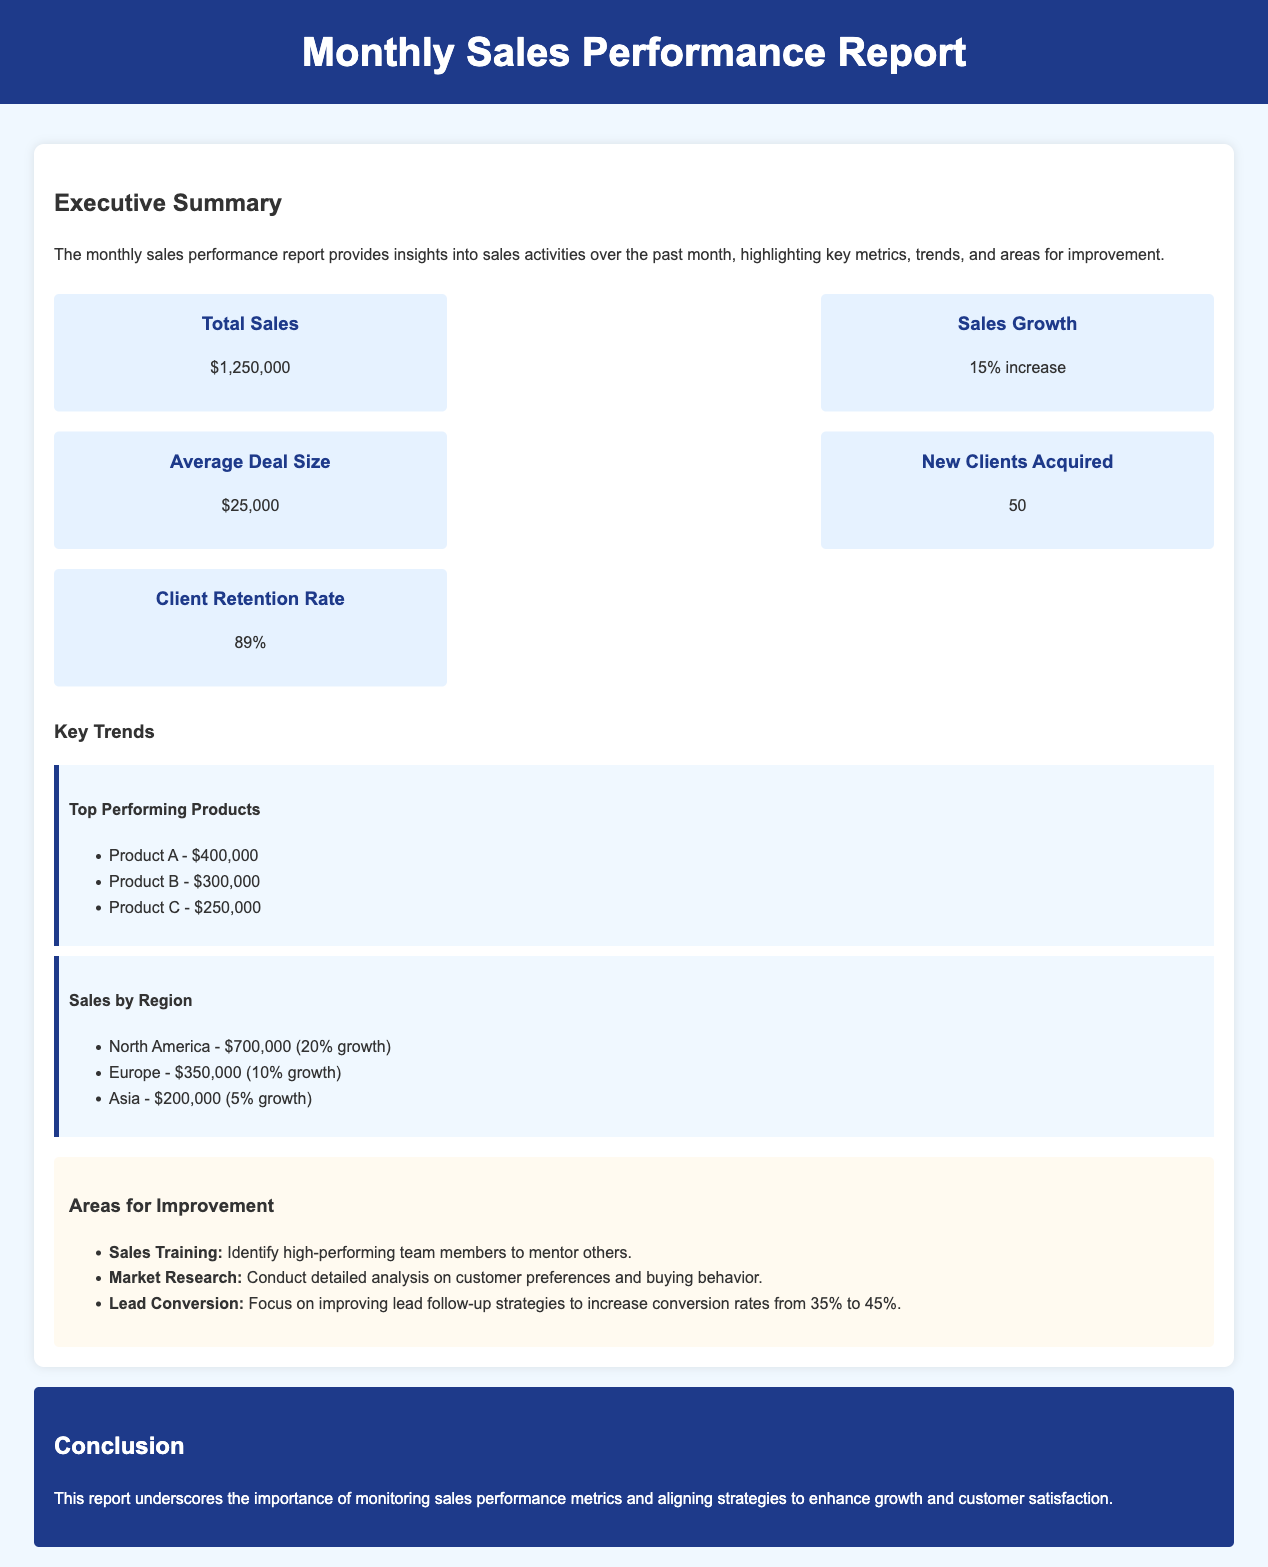What were the total sales for the month? The total sales are provided in the executive summary section of the document.
Answer: $1,250,000 What was the percentage increase in sales growth? The sales growth percentage is highlighted in the metrics section.
Answer: 15% increase How many new clients were acquired this month? The number of new clients acquired is stated in the metrics section.
Answer: 50 What is the client retention rate? The client retention rate is mentioned in the metrics section of the report.
Answer: 89% Which product generated the highest revenue? The top-performing products are listed in the trends section, showing the highest revenue.
Answer: Product A - $400,000 Which region experienced the highest sales growth? The sales by region section states the growth rates, allowing for determination of the highest growth.
Answer: North America - 20% growth What is the focus for improving lead conversion rates? The areas for improvement section indicates specific strategies to enhance lead conversion.
Answer: Improve lead follow-up strategies What is one of the proposed areas for sales training? The report suggests specific areas for improvement, including training tactics.
Answer: Identify high-performing team members to mentor others What conclusion is drawn about monitoring sales performance? The conclusion section sums up the report’s emphasis on the importance of metrics.
Answer: Importance of monitoring sales performance metrics 